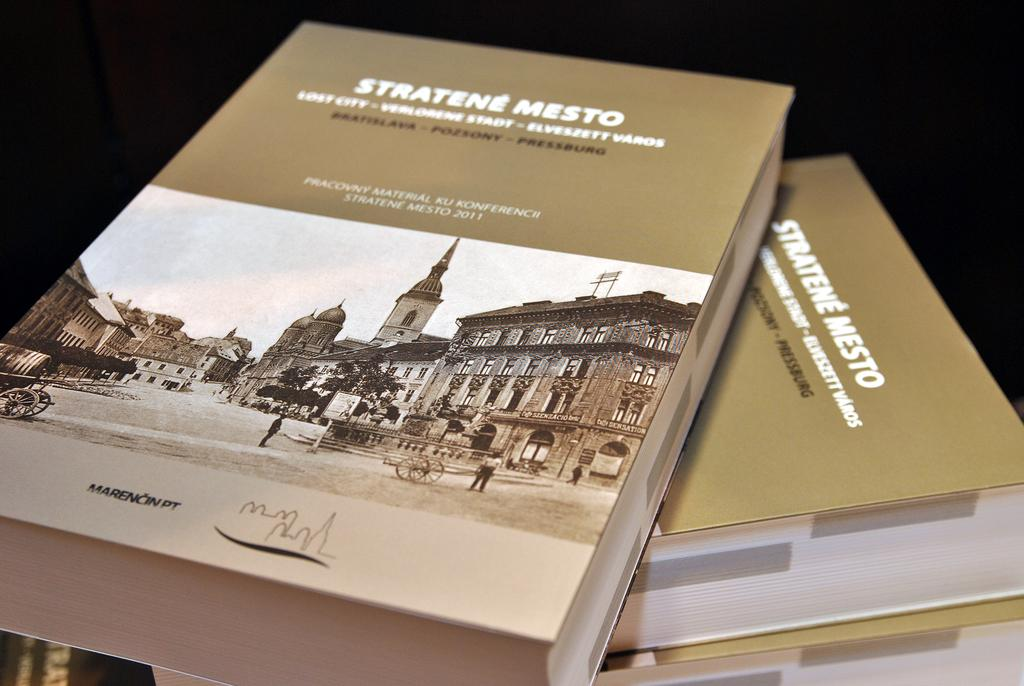What type of objects are present in the image? The image contains books. What color are the books? The books are in brown color. What color is the background of the image? The background of the image is black. How does the ground look like in the image? There is no ground visible in the image; it only contains books and a black background. 